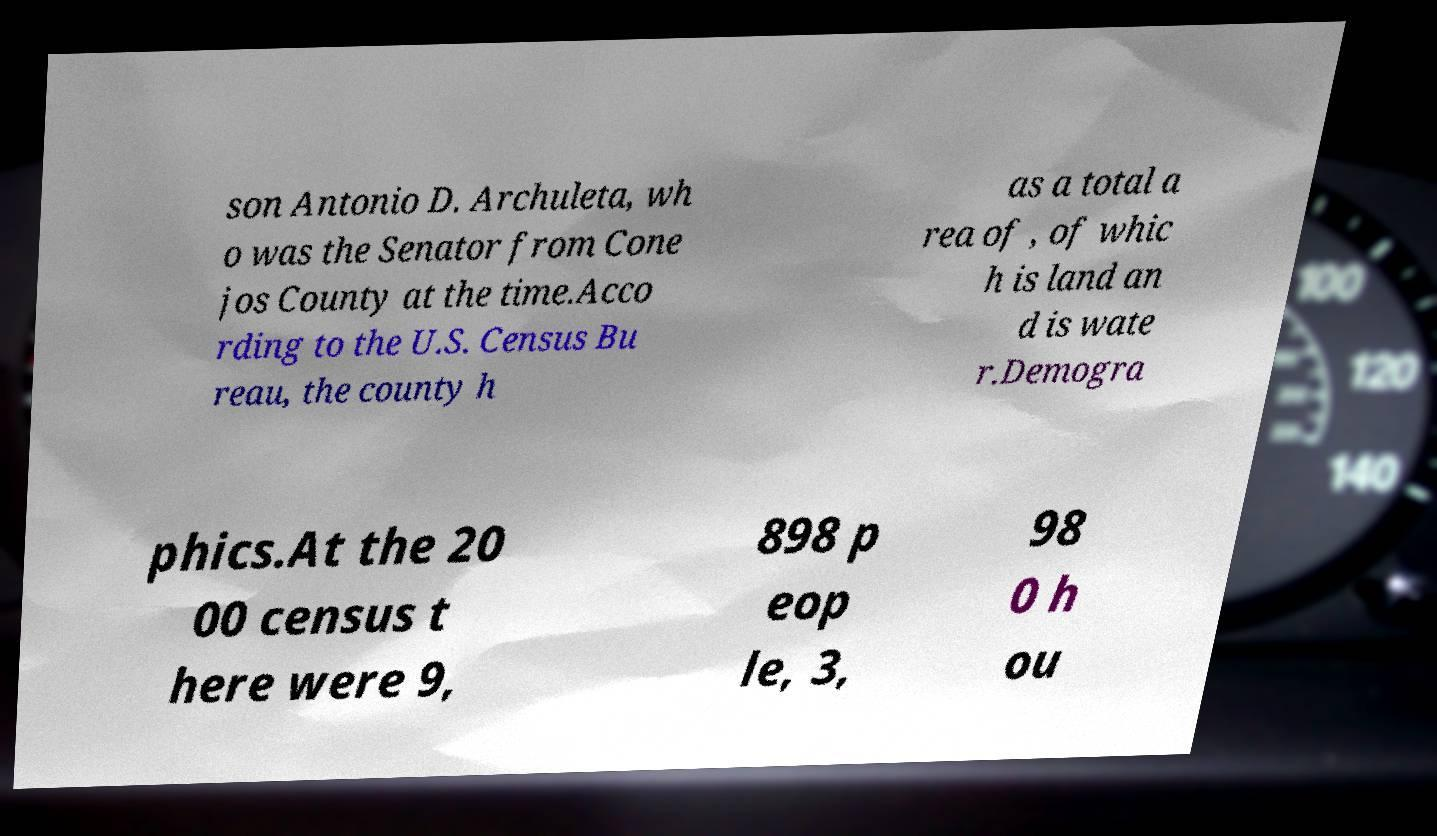Please read and relay the text visible in this image. What does it say? son Antonio D. Archuleta, wh o was the Senator from Cone jos County at the time.Acco rding to the U.S. Census Bu reau, the county h as a total a rea of , of whic h is land an d is wate r.Demogra phics.At the 20 00 census t here were 9, 898 p eop le, 3, 98 0 h ou 